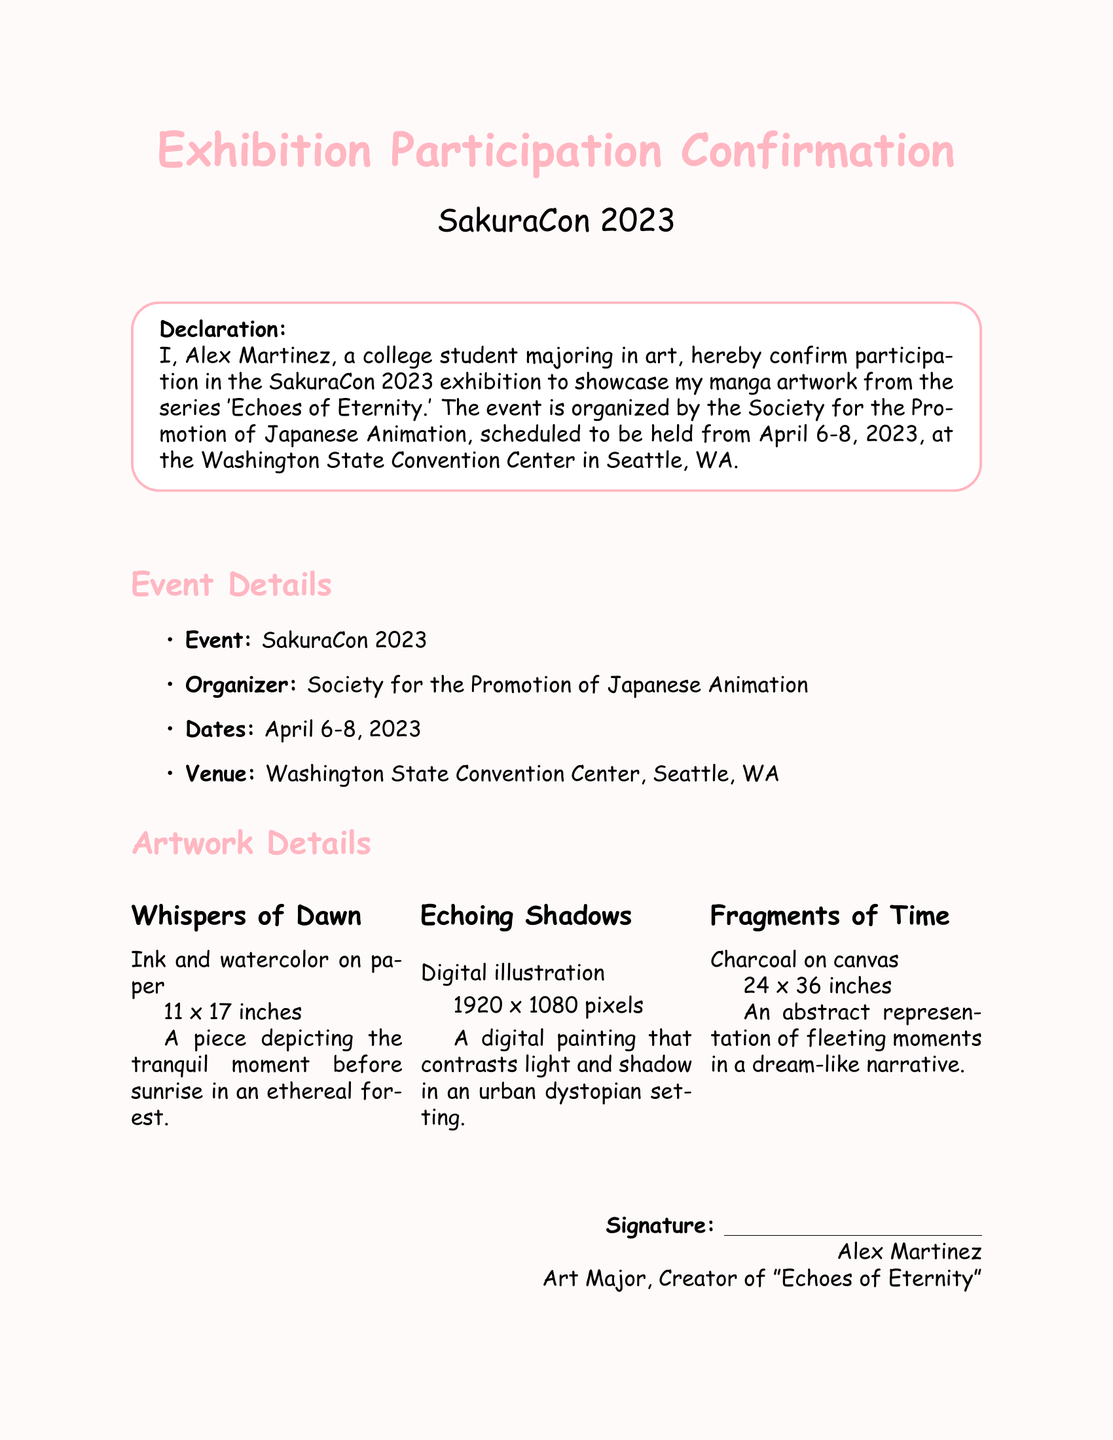What is the name of the event? The event name is explicitly stated in the document as "SakuraCon 2023."
Answer: SakuraCon 2023 Who is the organizer of the event? The document specifies that the event is organized by the "Society for the Promotion of Japanese Animation."
Answer: Society for the Promotion of Japanese Animation What are the dates of the exhibition? The specific dates of the exhibition are detailed in the document as "April 6-8, 2023."
Answer: April 6-8, 2023 What is the title of the artwork series being showcased? The declaration mentions the artwork series is titled "Echoes of Eternity."
Answer: Echoes of Eternity How many pieces are listed in the artwork details section? The document outlines three individual pieces of artwork, indicating the total count.
Answer: Three What is the medium used for "Whispers of Dawn"? The specific medium of the artwork "Whispers of Dawn" is mentioned as "Ink and watercolor on paper."
Answer: Ink and watercolor on paper What is the size of "Fragments of Time"? The document indicates that the size of "Fragments of Time" is "24 x 36 inches."
Answer: 24 x 36 inches Who is the signatory of the declaration? The document provides the name of the signatory as "Alex Martinez."
Answer: Alex Martinez What is the venue of the event? The document specifies the venue as the "Washington State Convention Center, Seattle, WA."
Answer: Washington State Convention Center, Seattle, WA 